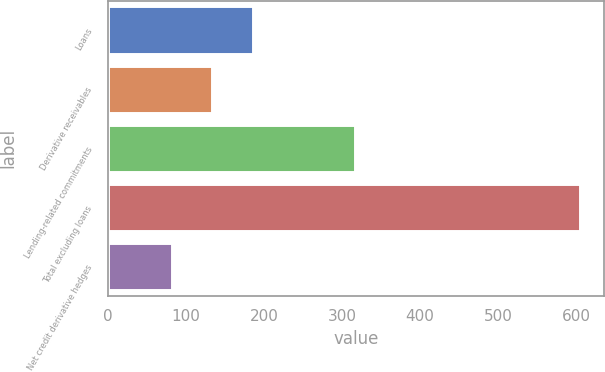<chart> <loc_0><loc_0><loc_500><loc_500><bar_chart><fcel>Loans<fcel>Derivative receivables<fcel>Lending-related commitments<fcel>Total excluding loans<fcel>Net credit derivative hedges<nl><fcel>186.6<fcel>134.3<fcel>317<fcel>605<fcel>82<nl></chart> 